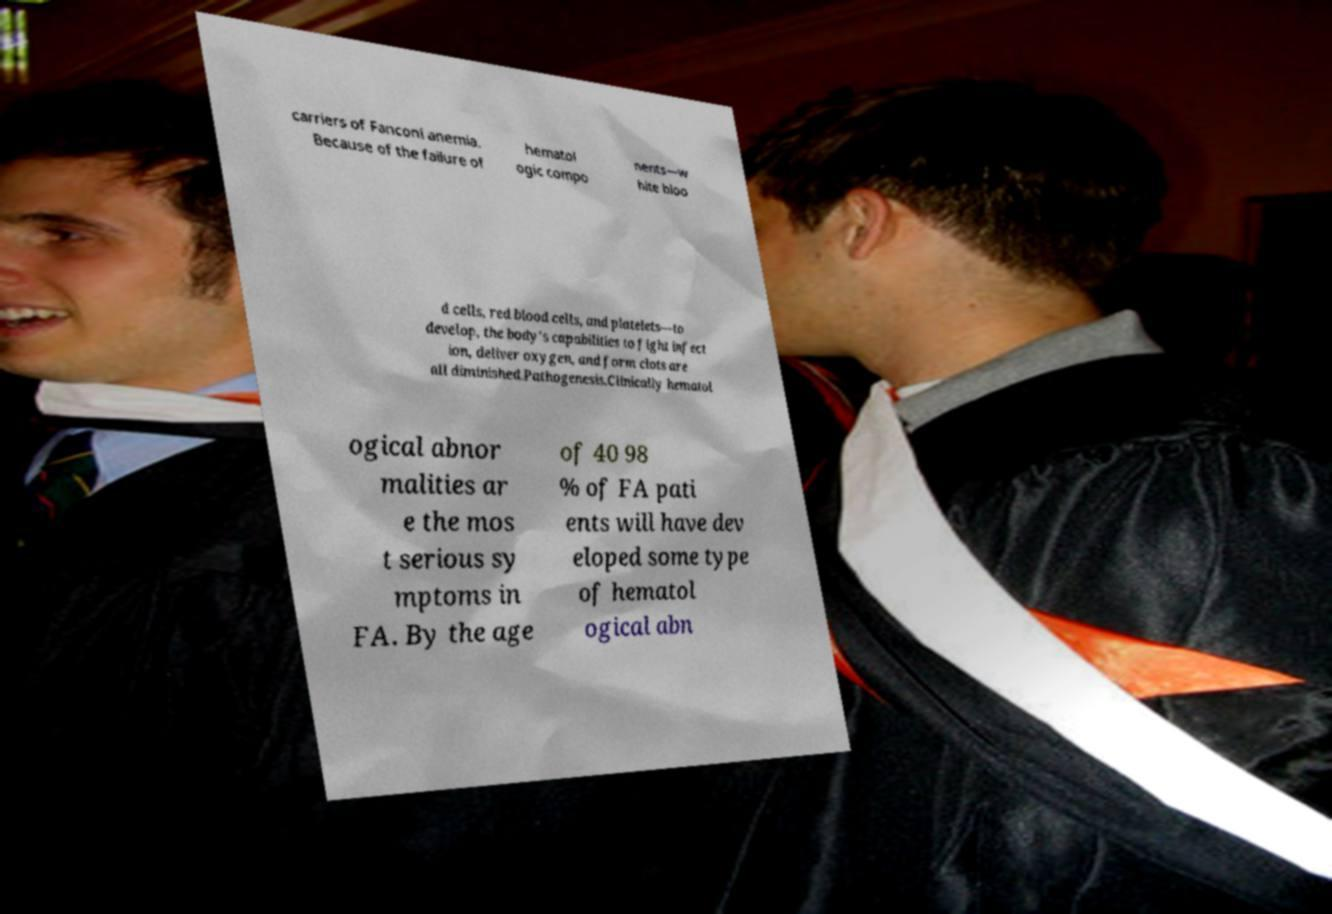Can you accurately transcribe the text from the provided image for me? carriers of Fanconi anemia. Because of the failure of hematol ogic compo nents—w hite bloo d cells, red blood cells, and platelets—to develop, the body's capabilities to fight infect ion, deliver oxygen, and form clots are all diminished.Pathogenesis.Clinically hematol ogical abnor malities ar e the mos t serious sy mptoms in FA. By the age of 40 98 % of FA pati ents will have dev eloped some type of hematol ogical abn 